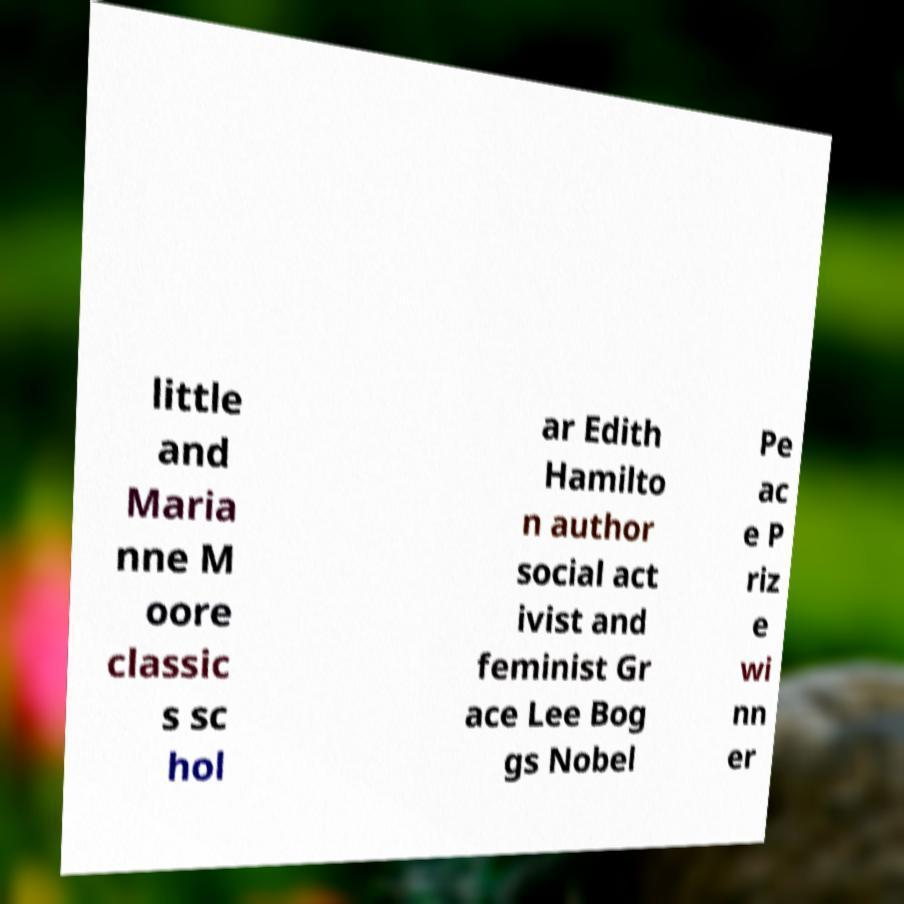Please identify and transcribe the text found in this image. little and Maria nne M oore classic s sc hol ar Edith Hamilto n author social act ivist and feminist Gr ace Lee Bog gs Nobel Pe ac e P riz e wi nn er 